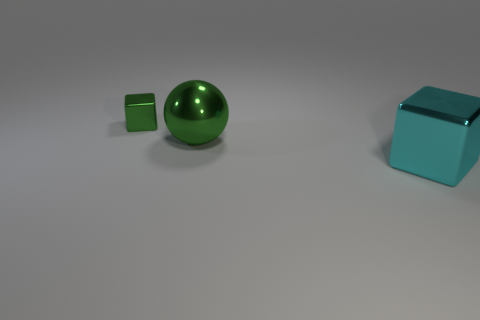There is a block that is behind the cyan block; is its color the same as the thing on the right side of the green metallic ball?
Give a very brief answer. No. How many blocks are either green objects or big cyan metallic things?
Your answer should be very brief. 2. Is the number of things that are in front of the big metallic block the same as the number of cyan shiny objects?
Provide a short and direct response. No. What is the green object left of the green metallic object in front of the shiny cube that is to the left of the big cube made of?
Give a very brief answer. Metal. There is a large sphere that is the same color as the tiny metal thing; what is it made of?
Provide a succinct answer. Metal. How many objects are either metal objects that are in front of the green sphere or gray rubber things?
Your answer should be very brief. 1. How many things are either cyan things or small green blocks to the left of the large cube?
Your answer should be compact. 2. There is a green thing that is to the right of the green shiny object that is on the left side of the large green shiny object; how many cyan cubes are in front of it?
Ensure brevity in your answer.  1. There is a block that is the same size as the green metallic sphere; what is its material?
Make the answer very short. Metal. Is there another purple metallic sphere that has the same size as the ball?
Ensure brevity in your answer.  No. 